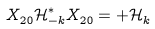Convert formula to latex. <formula><loc_0><loc_0><loc_500><loc_500>X ^ { \ } _ { 2 0 } \mathcal { H } ^ { * } _ { - k } X ^ { \ } _ { 2 0 } = + \mathcal { H } ^ { \ } _ { k }</formula> 